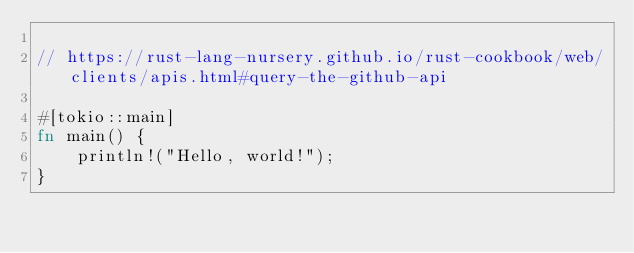<code> <loc_0><loc_0><loc_500><loc_500><_Rust_>
// https://rust-lang-nursery.github.io/rust-cookbook/web/clients/apis.html#query-the-github-api

#[tokio::main]
fn main() {
    println!("Hello, world!");
}
</code> 